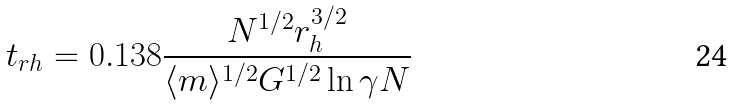<formula> <loc_0><loc_0><loc_500><loc_500>t _ { r h } = 0 . 1 3 8 \frac { N ^ { 1 / 2 } r _ { h } ^ { 3 / 2 } } { \langle m \rangle ^ { 1 / 2 } G ^ { 1 / 2 } \ln \gamma N }</formula> 